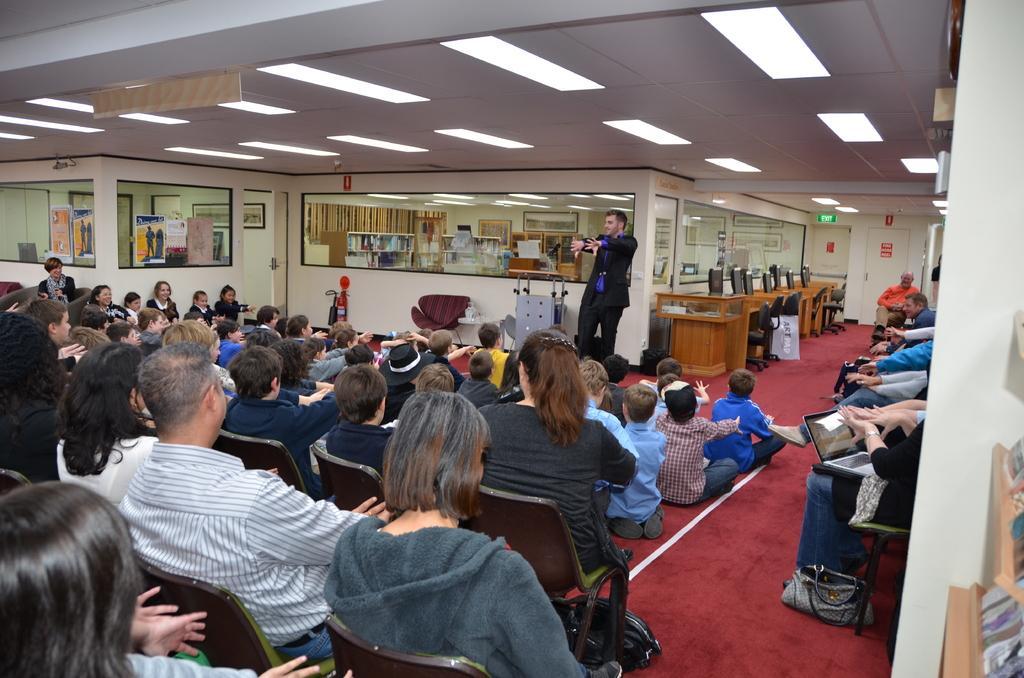Describe this image in one or two sentences. In the picture we can some people are sitting on the chairs and front of them, we can see some people are sitting on the floor and in front of them, we can see a man standing and doing some action and in the background, we can see some cabins with glasses to it and beside it we can see some computer systems on the desks and to the ceiling we can see the lights. 